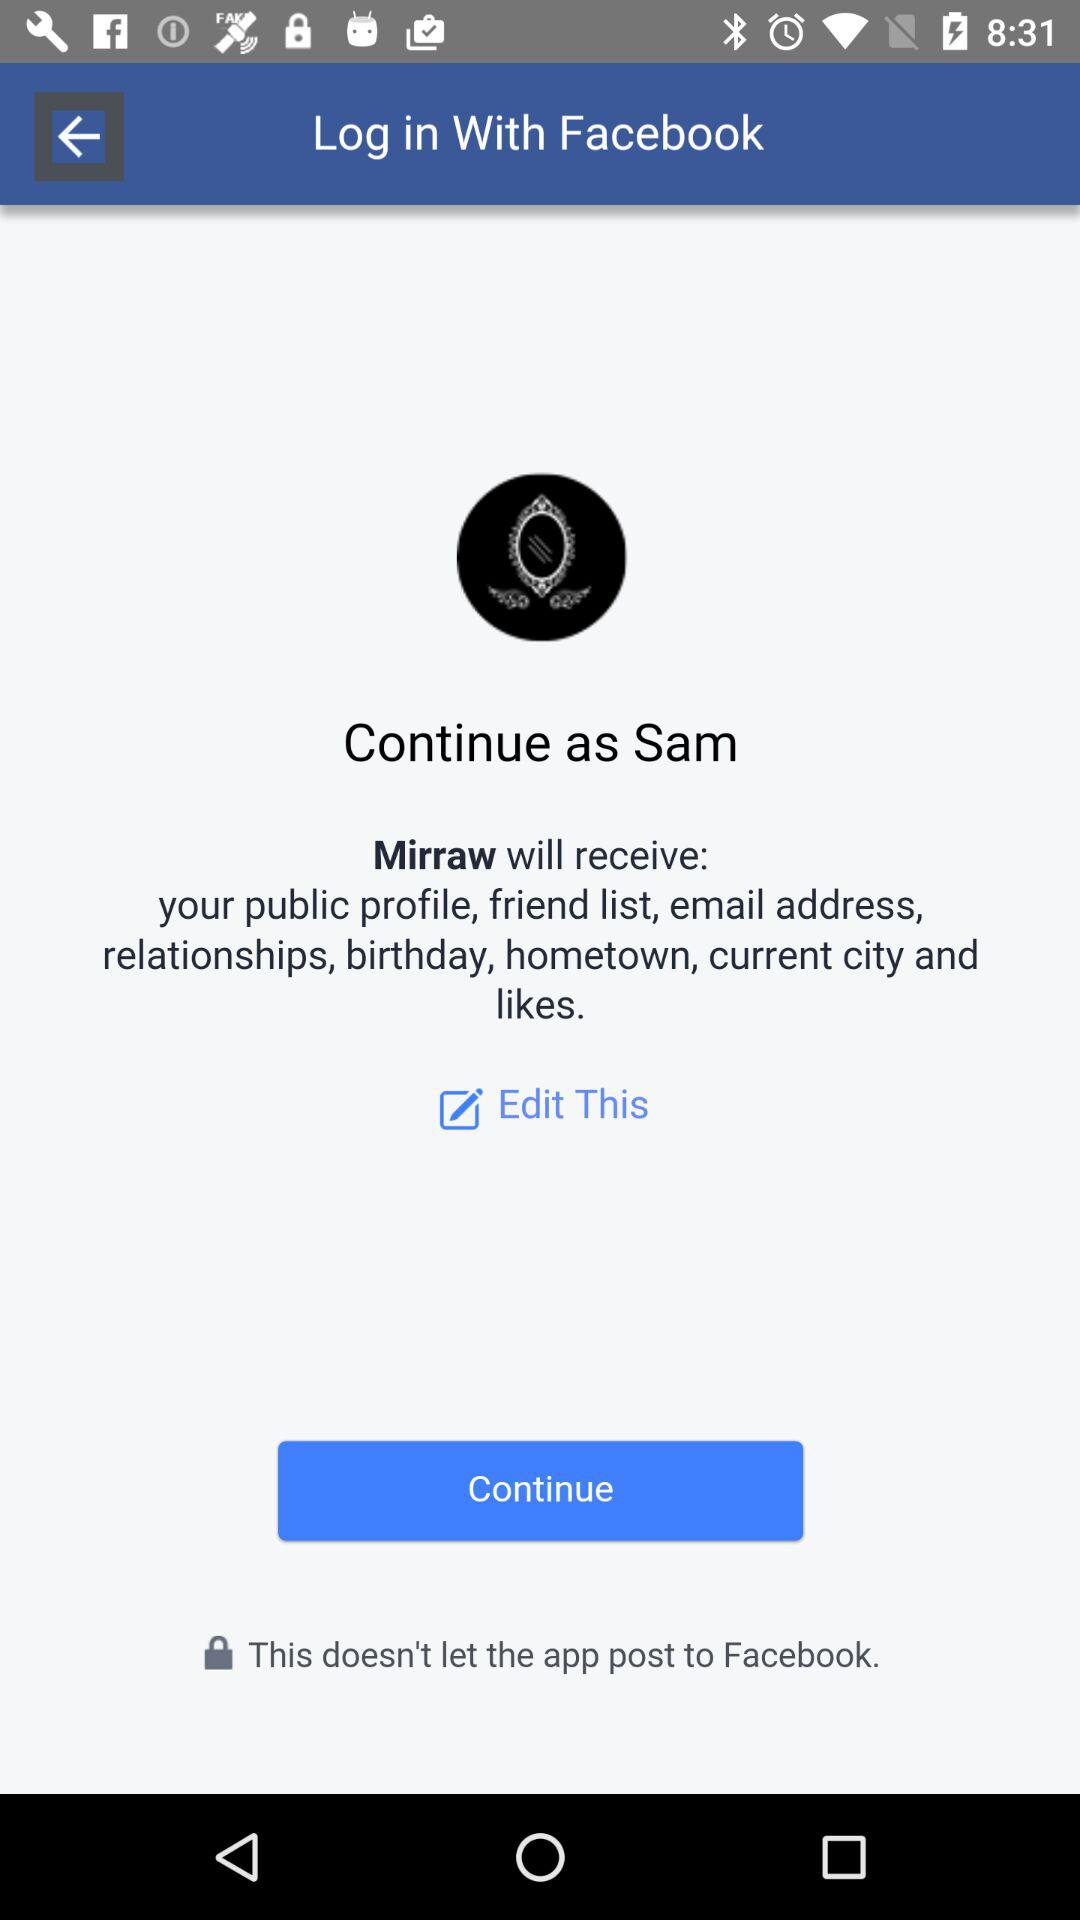What is the information provided in "Edit This"?
When the provided information is insufficient, respond with <no answer>. <no answer> 